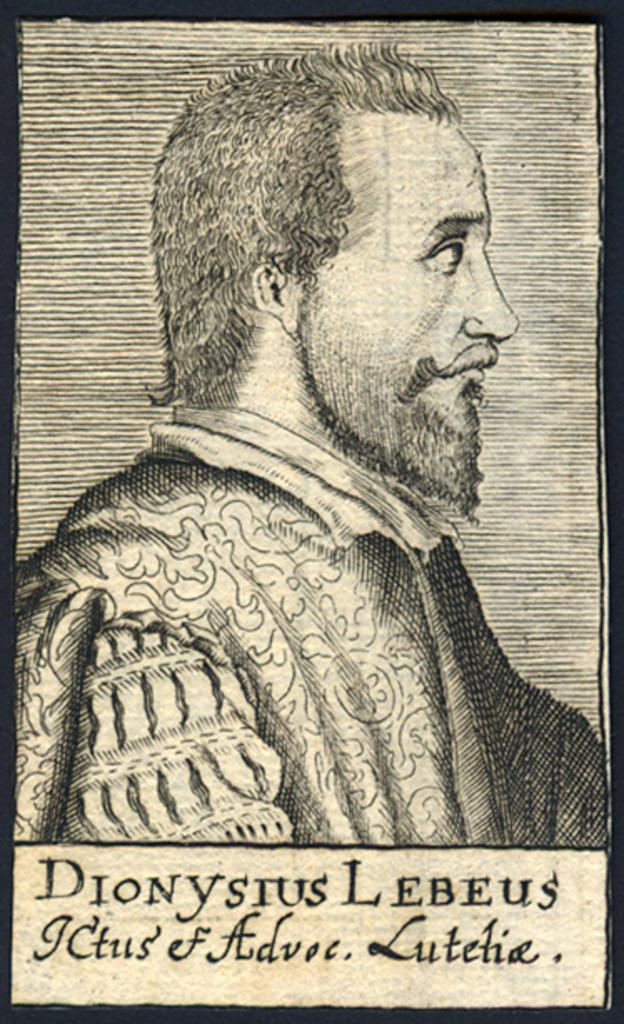What is featured on the poster in the image? There is a poster in the image, and it contains a picture of a man. What can be observed about the man in the picture? The man in the picture is wearing clothes. Is there any text on the poster? Yes, there is text on the poster. Can you tell me how many ducks are sitting on the desk in the image? There are no ducks or desks present in the image; it only features a poster with a picture of a man and text. 